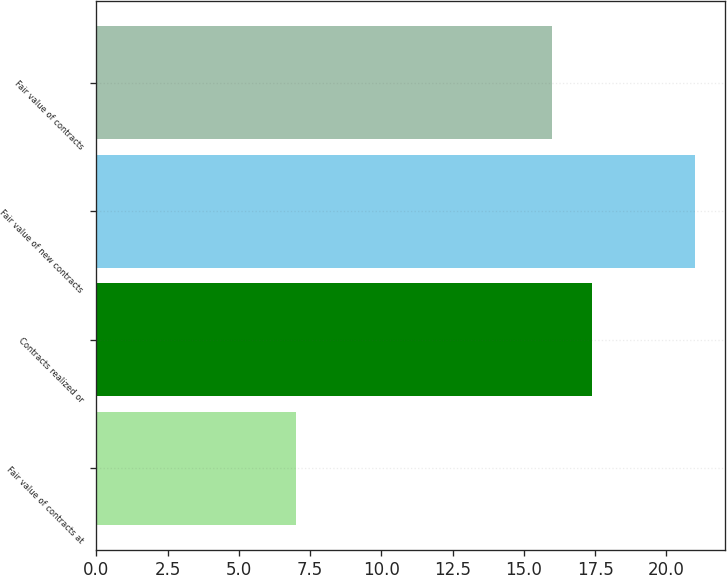Convert chart to OTSL. <chart><loc_0><loc_0><loc_500><loc_500><bar_chart><fcel>Fair value of contracts at<fcel>Contracts realized or<fcel>Fair value of new contracts<fcel>Fair value of contracts<nl><fcel>7<fcel>17.4<fcel>21<fcel>16<nl></chart> 